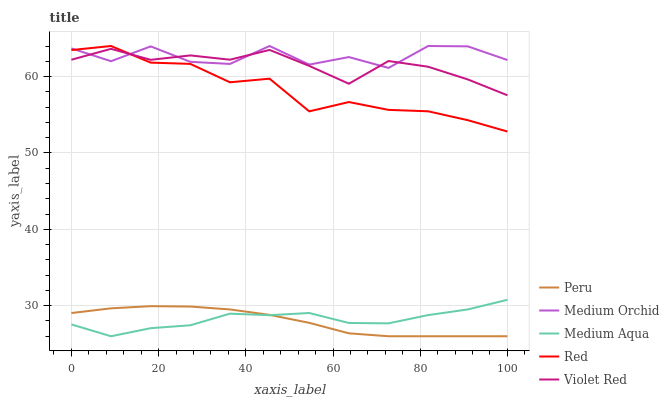Does Peru have the minimum area under the curve?
Answer yes or no. Yes. Does Medium Orchid have the maximum area under the curve?
Answer yes or no. Yes. Does Medium Aqua have the minimum area under the curve?
Answer yes or no. No. Does Medium Aqua have the maximum area under the curve?
Answer yes or no. No. Is Peru the smoothest?
Answer yes or no. Yes. Is Medium Orchid the roughest?
Answer yes or no. Yes. Is Medium Aqua the smoothest?
Answer yes or no. No. Is Medium Aqua the roughest?
Answer yes or no. No. Does Medium Aqua have the lowest value?
Answer yes or no. Yes. Does Medium Orchid have the lowest value?
Answer yes or no. No. Does Red have the highest value?
Answer yes or no. Yes. Does Medium Aqua have the highest value?
Answer yes or no. No. Is Medium Aqua less than Medium Orchid?
Answer yes or no. Yes. Is Red greater than Peru?
Answer yes or no. Yes. Does Red intersect Medium Orchid?
Answer yes or no. Yes. Is Red less than Medium Orchid?
Answer yes or no. No. Is Red greater than Medium Orchid?
Answer yes or no. No. Does Medium Aqua intersect Medium Orchid?
Answer yes or no. No. 